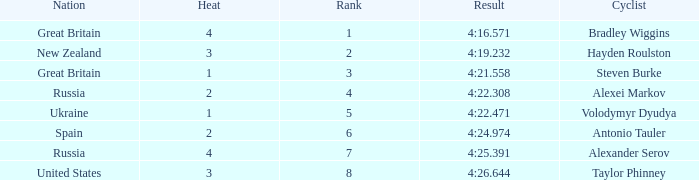What is the lowest rank that spain got? 6.0. 